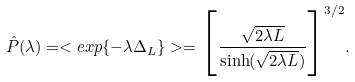<formula> <loc_0><loc_0><loc_500><loc_500>\hat { P } ( \lambda ) = < e x p \{ - \lambda \Delta _ { L } \} > = \Big { [ } \frac { \sqrt { 2 \lambda L } } { \sinh ( \sqrt { 2 \lambda L } ) } \Big { ] } ^ { 3 / 2 } .</formula> 